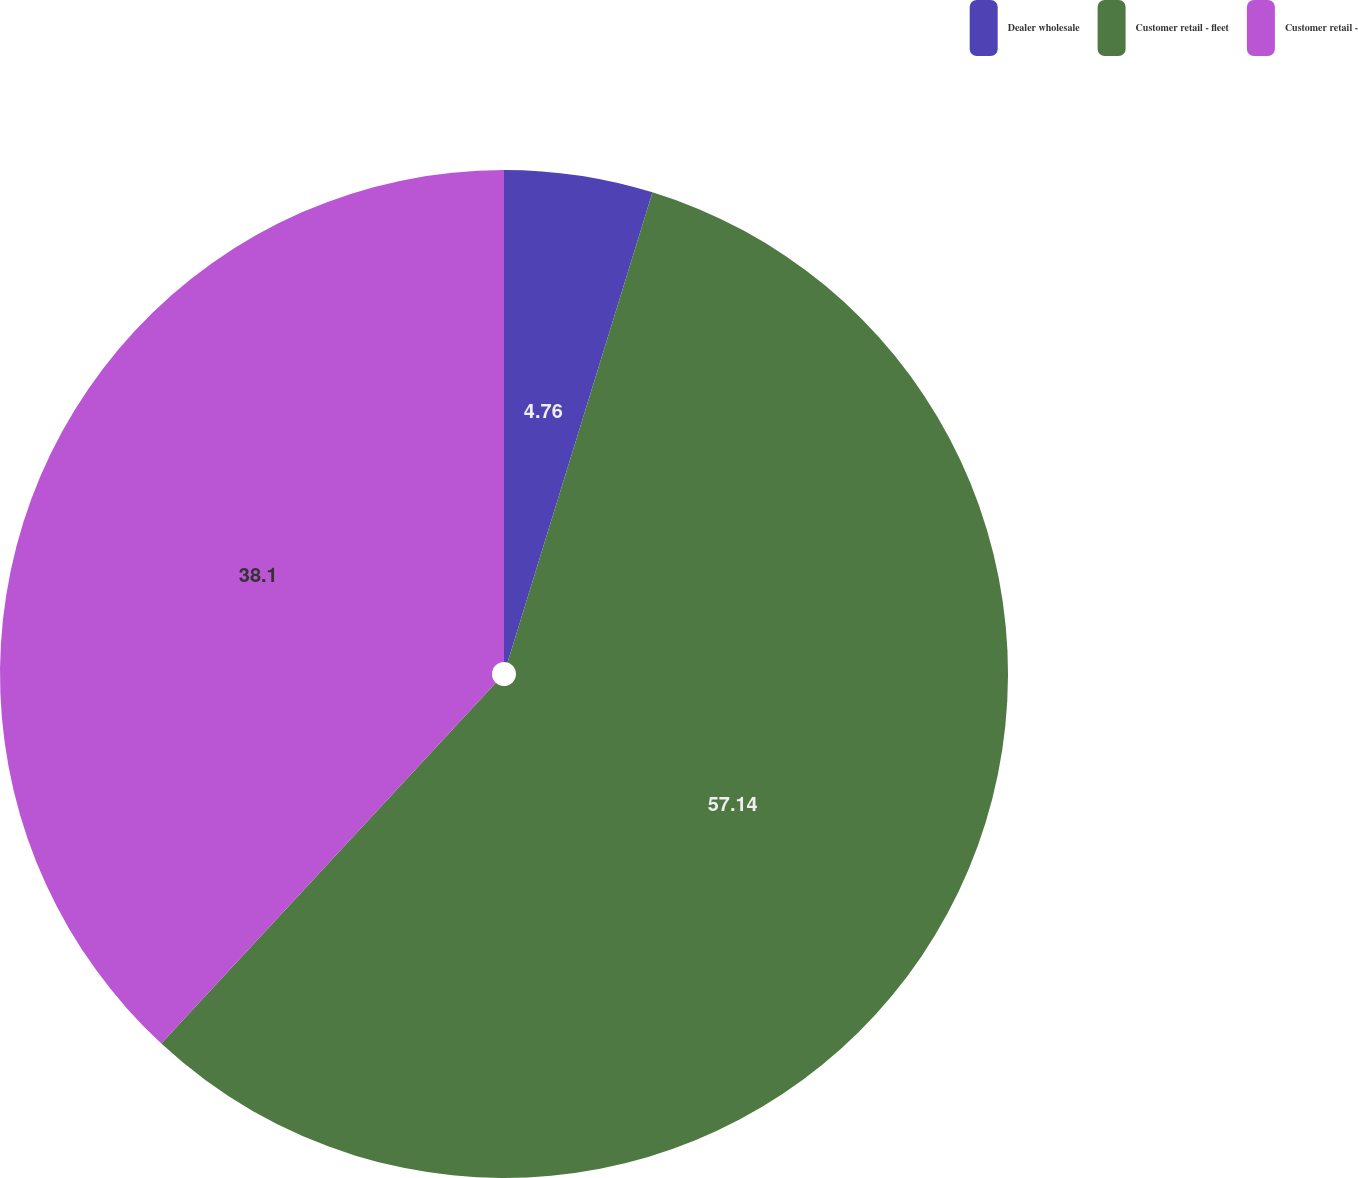<chart> <loc_0><loc_0><loc_500><loc_500><pie_chart><fcel>Dealer wholesale<fcel>Customer retail - fleet<fcel>Customer retail -<nl><fcel>4.76%<fcel>57.14%<fcel>38.1%<nl></chart> 